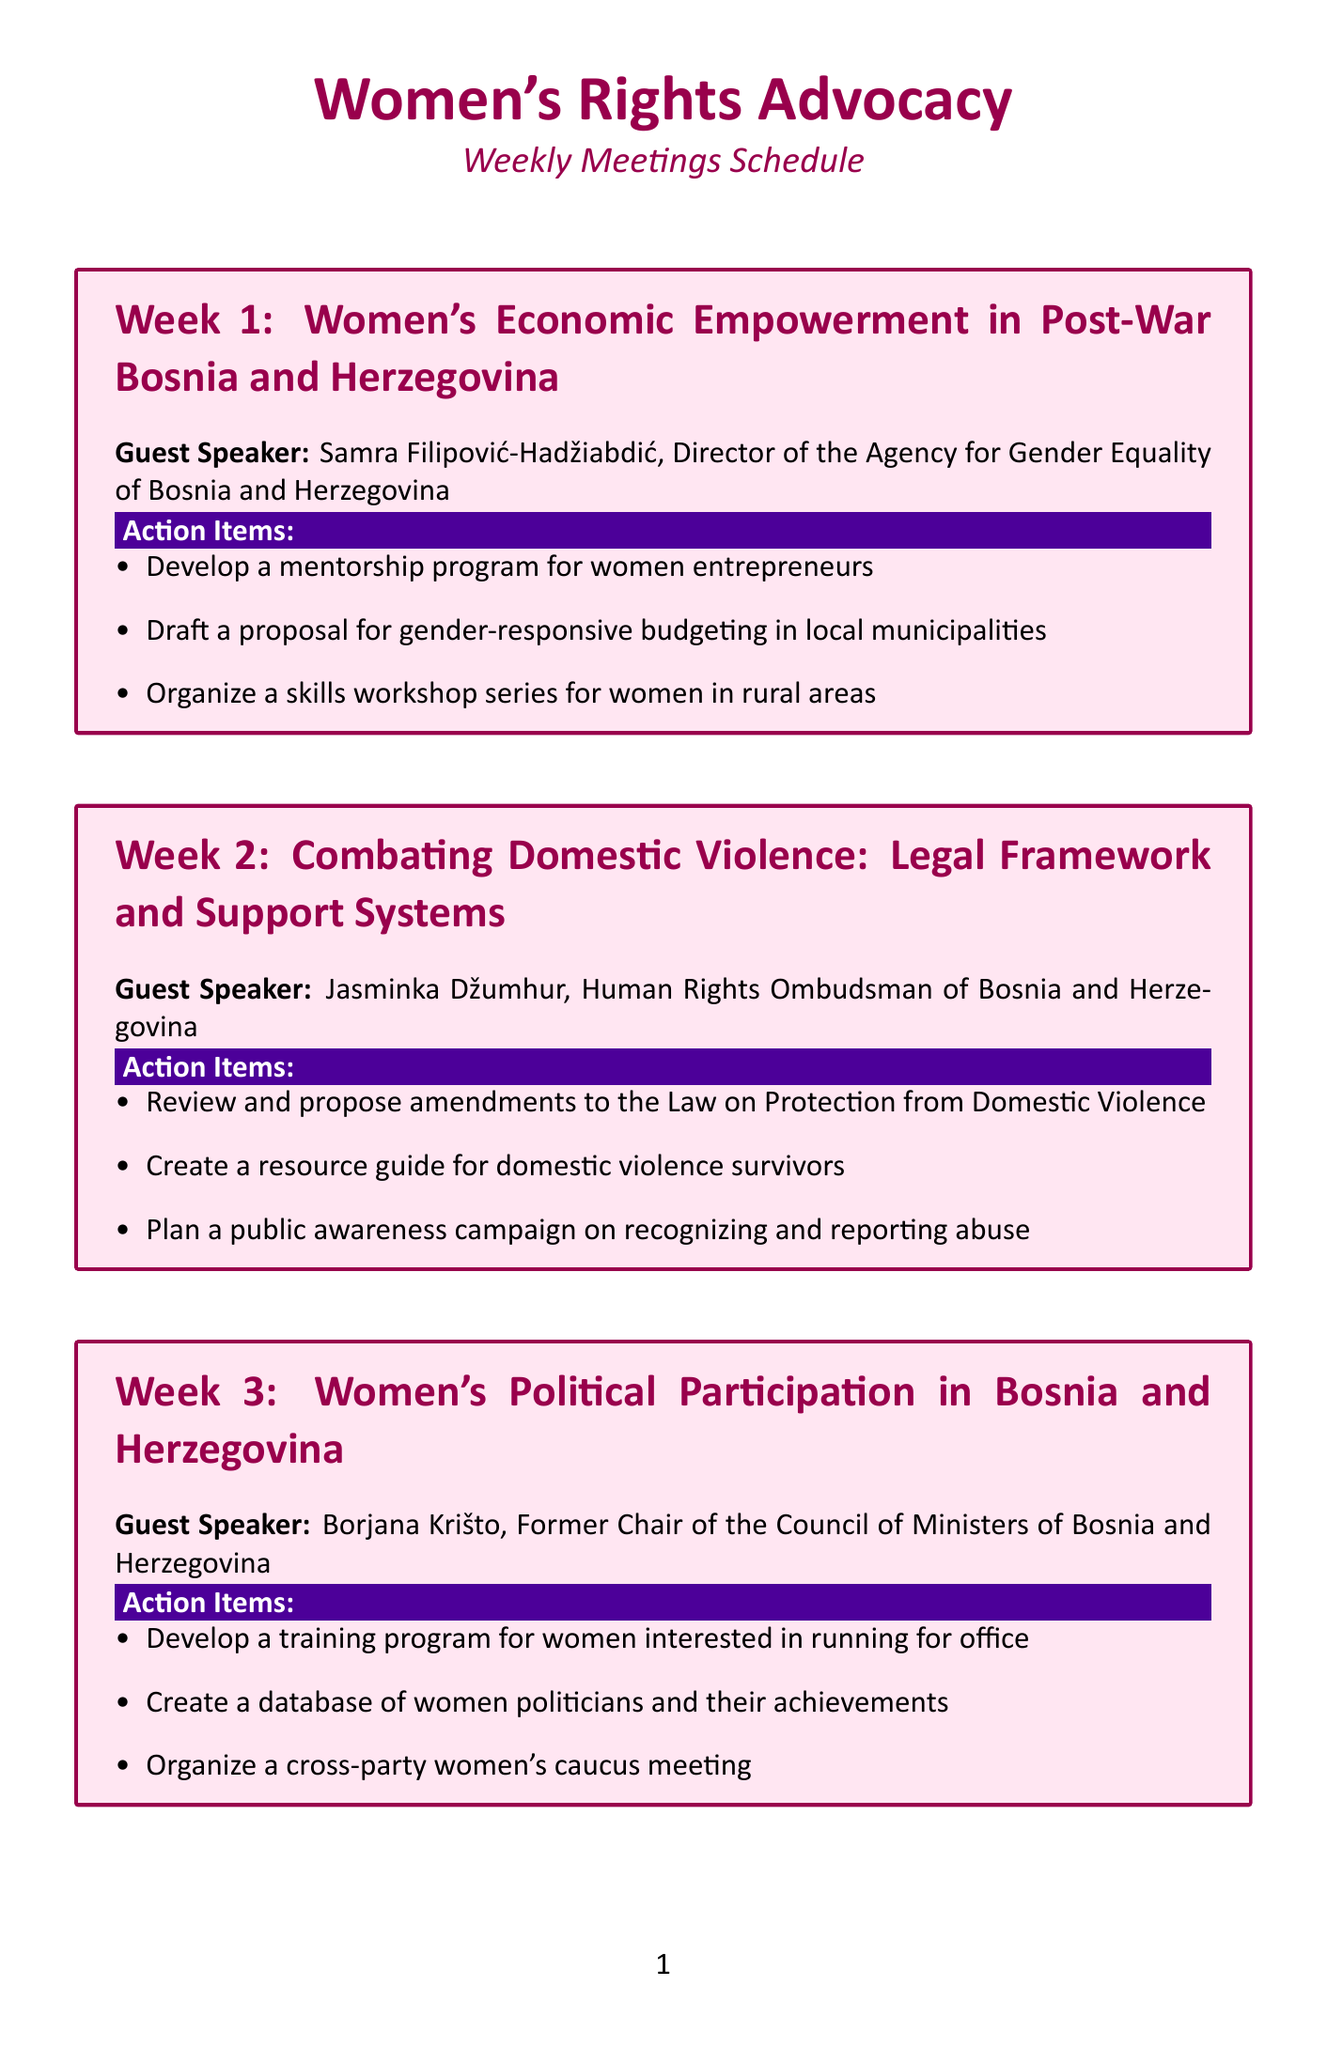what is the topic for week 1? The topic for week 1 is specified under the section title for that week.
Answer: Women's Economic Empowerment in Post-War Bosnia and Herzegovina who is the guest speaker for week 3? The name of the guest speaker is listed in the respective box for week 3.
Answer: Borjana Krišto, Former Chair of the Council of Ministers of Bosnia and Herzegovina how many action items are listed for week 5? The action items are listed in bullet points for week 5.
Answer: 3 what is one action item for addressing gender-based violence? The action items are detailed in the section for week 6.
Answer: Organize a support group for survivors of wartime sexual violence which guest speaker is involved with women's health rights? The guest speaker's name is provided in the context of week 4, which pertains to women's health rights.
Answer: Dr. Mirsada Hukić which action item aims to improve women's political participation? The action items under week 3 describe the actions related to political participation.
Answer: Develop a training program for women interested in running for office what is the focus of week 2's topic? The specific focus is identified in the overview of week 2.
Answer: Combating Domestic Violence: Legal Framework and Support Systems who is the guest speaker for the final week? The name of the guest speaker is mentioned in the section for week 6.
Answer: Bakira Hasečić, President of the Association of Women Victims of War 